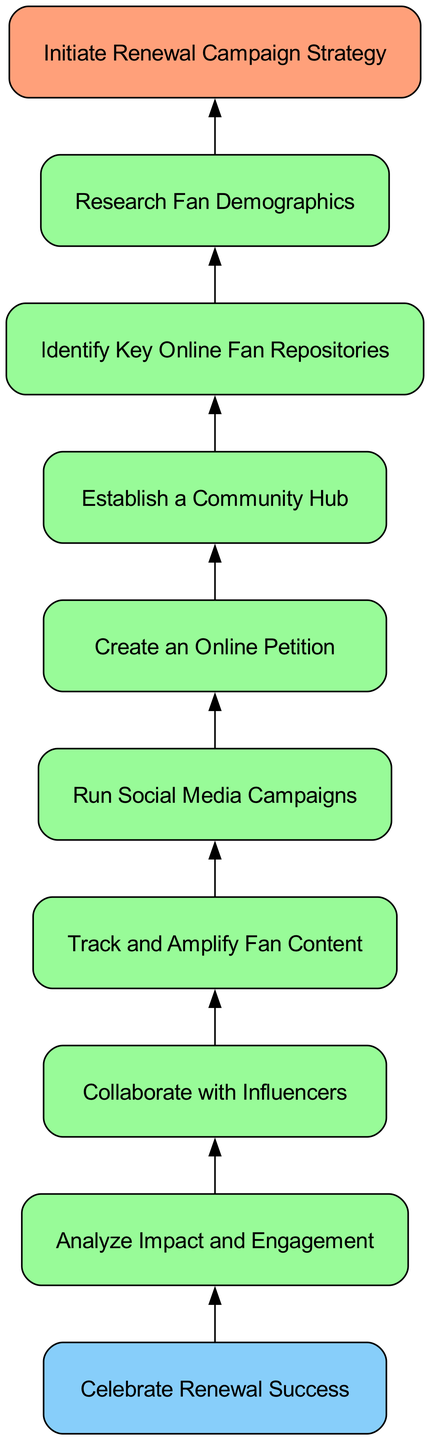What's the starting point of the flowchart? The flowchart starts with the node labeled "Initiate Renewal Campaign Strategy". This is the first item in the diagram and is positioned at the bottom.
Answer: Initiate Renewal Campaign Strategy What type of node is "Celebrate Renewal Success"? The node "Celebrate Renewal Success" is categorized as an "End" type node. This can be identified by its label and the shape or color associated with it in the diagram.
Answer: End How many process nodes are in the flowchart? By counting all the nodes classified under "Process", there are seven process nodes present in the diagram.
Answer: Seven What is the relationship between "Run Social Media Campaigns" and "Collaborate with Influencers"? "Run Social Media Campaigns" follows "Collaborate with Influencers" in the flow, indicating that the latter is a prerequisite or contributing step before executing social media campaigns.
Answer: Sequential Which node precedes "Create an Online Petition"? The node that comes before "Create an Online Petition" is "Establish a Community Hub". This can be determined by the flow direction showing the order of execution.
Answer: Establish a Community Hub Which node has the last action in the diagram? The last action described in the diagram is "Celebrate Renewal Success", which represents the conclusion of the flow after all previous actions have been completed.
Answer: Celebrate Renewal Success How many edges connect the nodes in the flowchart? By tracing the connections from the start node to the end node, there are eight edges that link all the nodes in the flowchart.
Answer: Eight What key online fan repositories need to be identified before creating an online petition? Before creating an online petition, "Identify Key Online Fan Repositories" should be addressed. This can be figured out by following the steps leading up to that action.
Answer: Identify Key Online Fan Repositories 